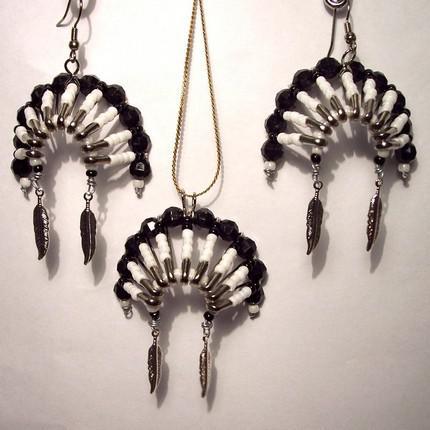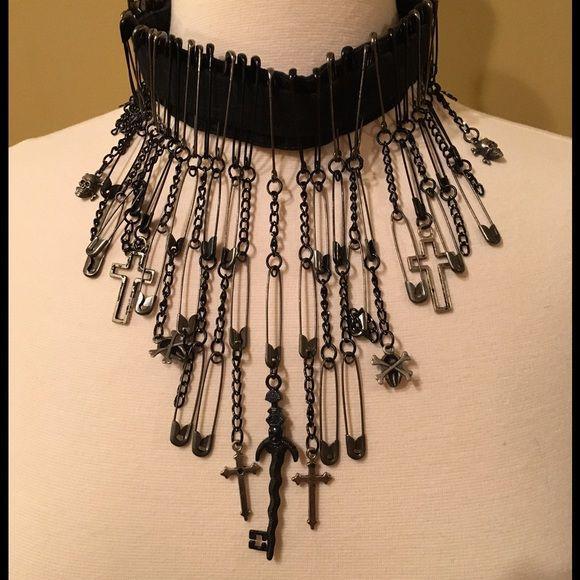The first image is the image on the left, the second image is the image on the right. Examine the images to the left and right. Is the description "The jewelry in the image on the right is made from safety pins" accurate? Answer yes or no. Yes. The first image is the image on the left, the second image is the image on the right. Considering the images on both sides, is "An image features a jacket with an embellished studded lapel." valid? Answer yes or no. No. 